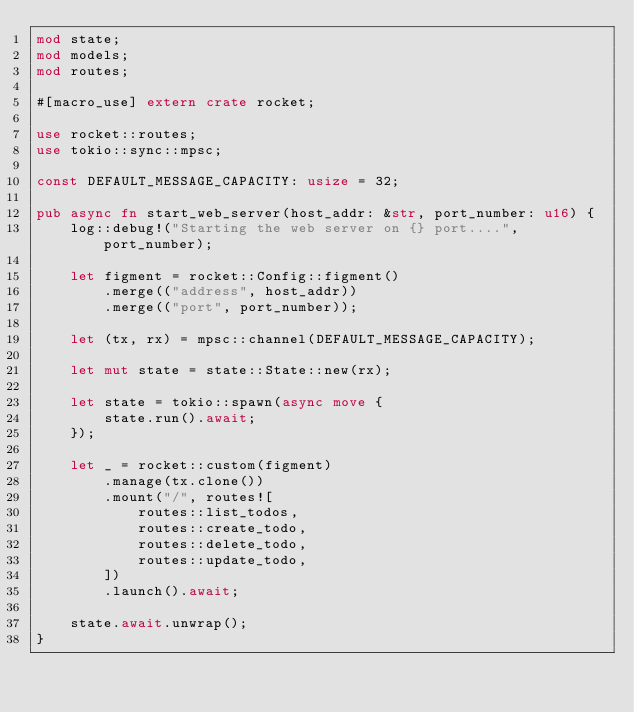Convert code to text. <code><loc_0><loc_0><loc_500><loc_500><_Rust_>mod state;
mod models;
mod routes;

#[macro_use] extern crate rocket;

use rocket::routes;
use tokio::sync::mpsc;

const DEFAULT_MESSAGE_CAPACITY: usize = 32;

pub async fn start_web_server(host_addr: &str, port_number: u16) {
    log::debug!("Starting the web server on {} port....", port_number);

    let figment = rocket::Config::figment()
        .merge(("address", host_addr))
        .merge(("port", port_number));

    let (tx, rx) = mpsc::channel(DEFAULT_MESSAGE_CAPACITY);

    let mut state = state::State::new(rx);

    let state = tokio::spawn(async move {
        state.run().await;
    });

    let _ = rocket::custom(figment)
        .manage(tx.clone())
        .mount("/", routes![
            routes::list_todos,
            routes::create_todo,
            routes::delete_todo,
            routes::update_todo,
        ])
        .launch().await;

    state.await.unwrap();
}
</code> 